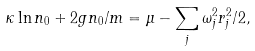<formula> <loc_0><loc_0><loc_500><loc_500>\kappa \ln n _ { 0 } + 2 g n _ { 0 } / m = \mu - \sum _ { j } \omega _ { j } ^ { 2 } r _ { j } ^ { 2 } / 2 ,</formula> 